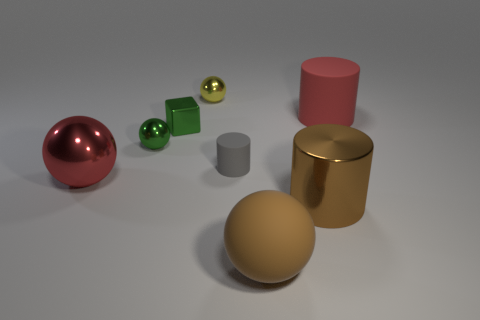Is the size of the shiny sphere that is behind the big red matte cylinder the same as the metallic thing left of the green ball?
Provide a succinct answer. No. What color is the other big metallic thing that is the same shape as the gray object?
Make the answer very short. Brown. Is the number of small rubber cylinders that are behind the tiny gray cylinder greater than the number of green metal balls in front of the metallic cylinder?
Offer a terse response. No. There is a metal sphere that is behind the red thing that is on the right side of the large red ball that is in front of the cube; how big is it?
Your answer should be very brief. Small. Is the material of the yellow thing the same as the red object that is in front of the red cylinder?
Keep it short and to the point. Yes. Is the shape of the yellow thing the same as the tiny gray thing?
Offer a terse response. No. How many other things are there of the same material as the yellow thing?
Ensure brevity in your answer.  4. What number of big red rubber objects have the same shape as the red shiny thing?
Your response must be concise. 0. What color is the shiny thing that is both in front of the yellow object and right of the tiny metal cube?
Keep it short and to the point. Brown. What number of yellow objects are there?
Offer a very short reply. 1. 